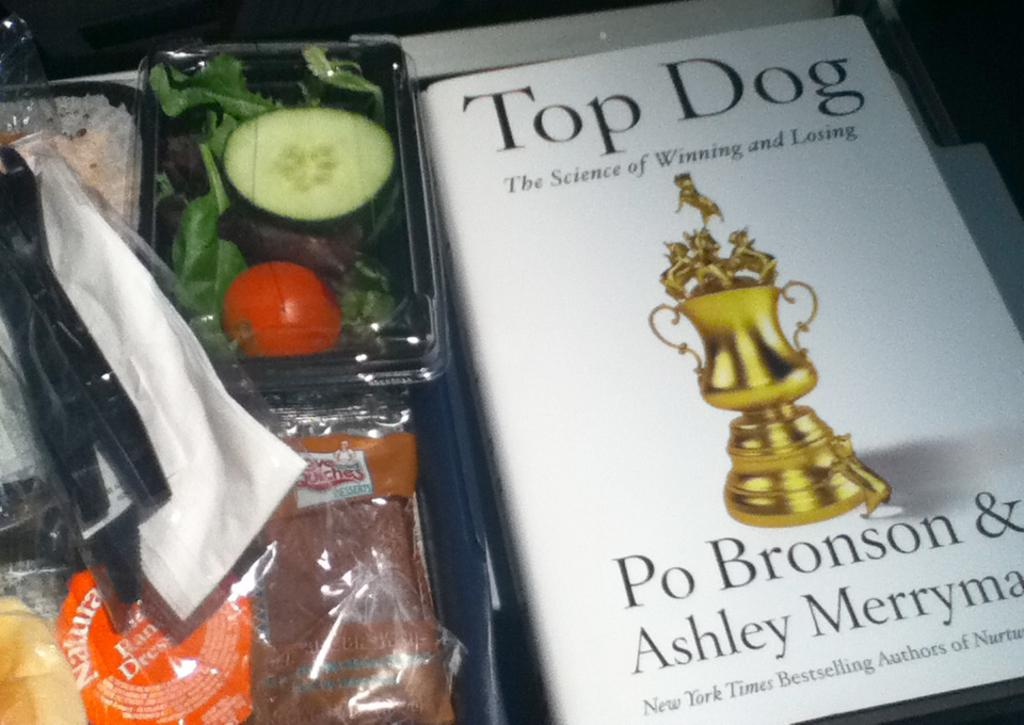<image>
Share a concise interpretation of the image provided. A to go lunch and a book called Top Dog (The Science of Winning and Losing) written by Po Bronson & Ashley Merryman. 